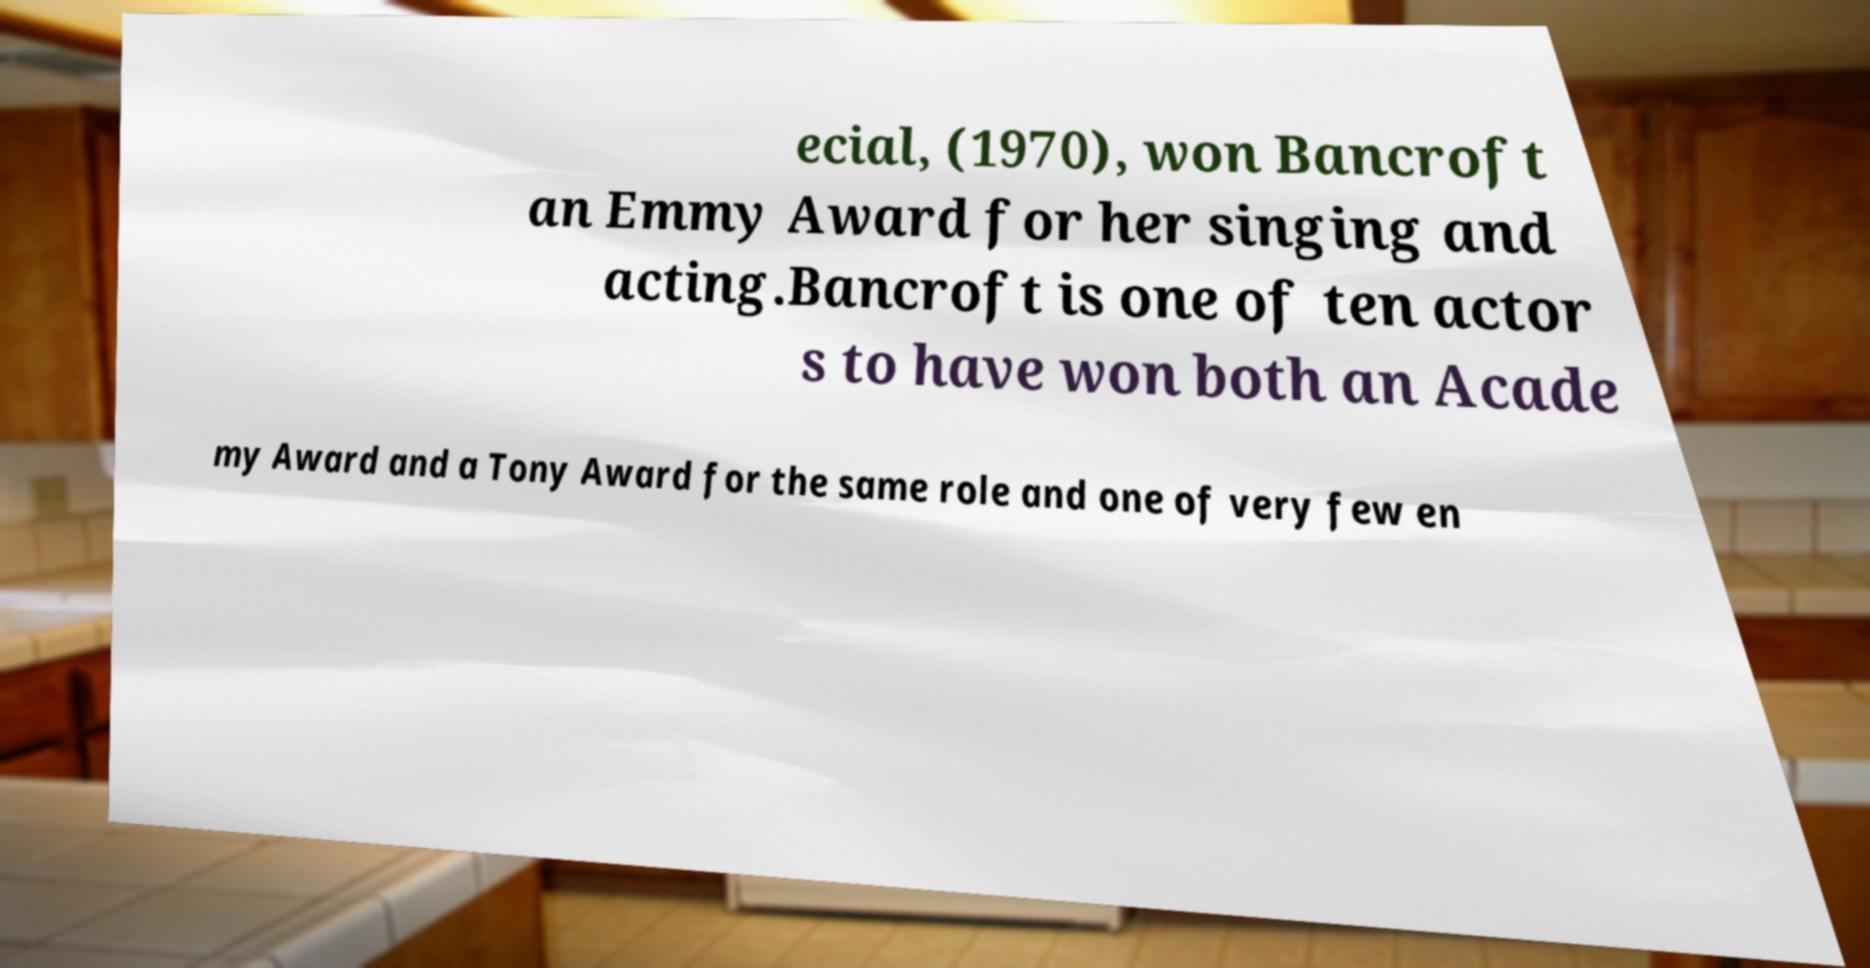For documentation purposes, I need the text within this image transcribed. Could you provide that? ecial, (1970), won Bancroft an Emmy Award for her singing and acting.Bancroft is one of ten actor s to have won both an Acade my Award and a Tony Award for the same role and one of very few en 